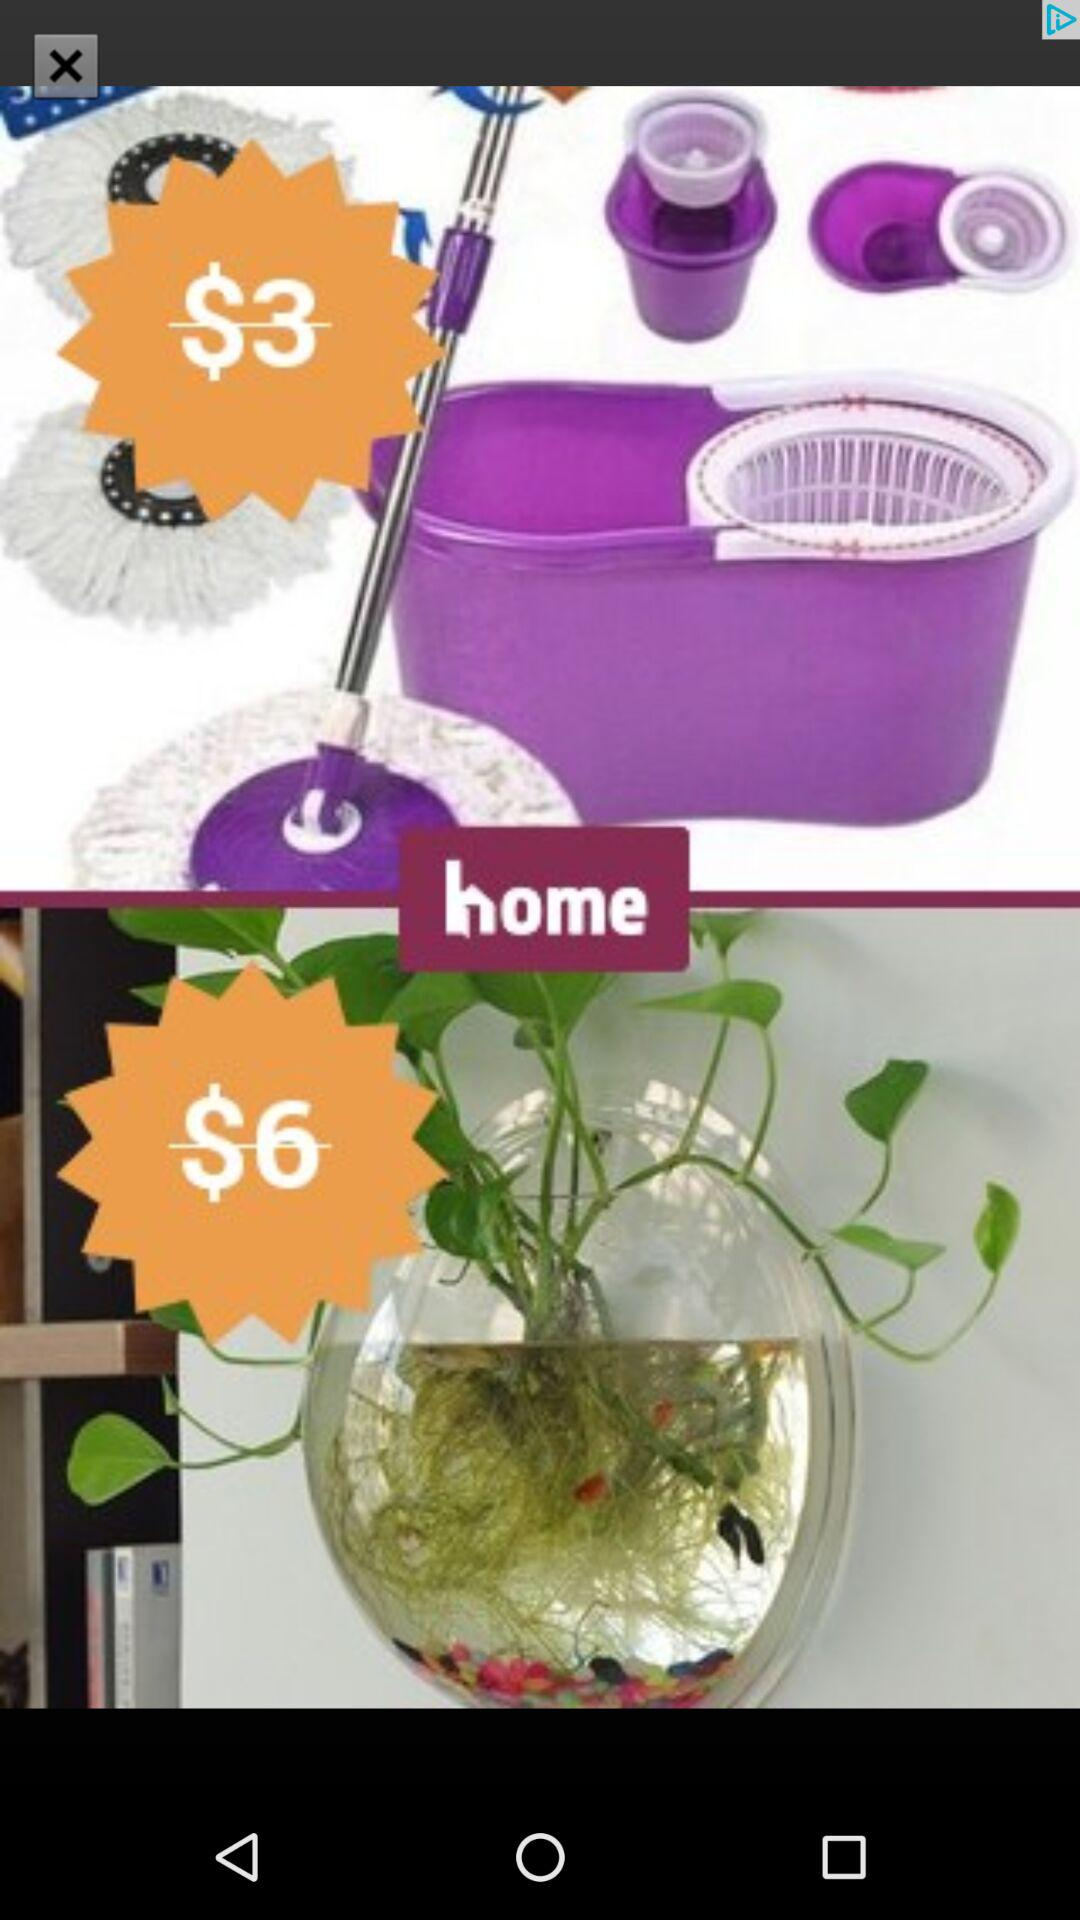How many more dollars is the cheapest option than the most expensive option?
Answer the question using a single word or phrase. 3 